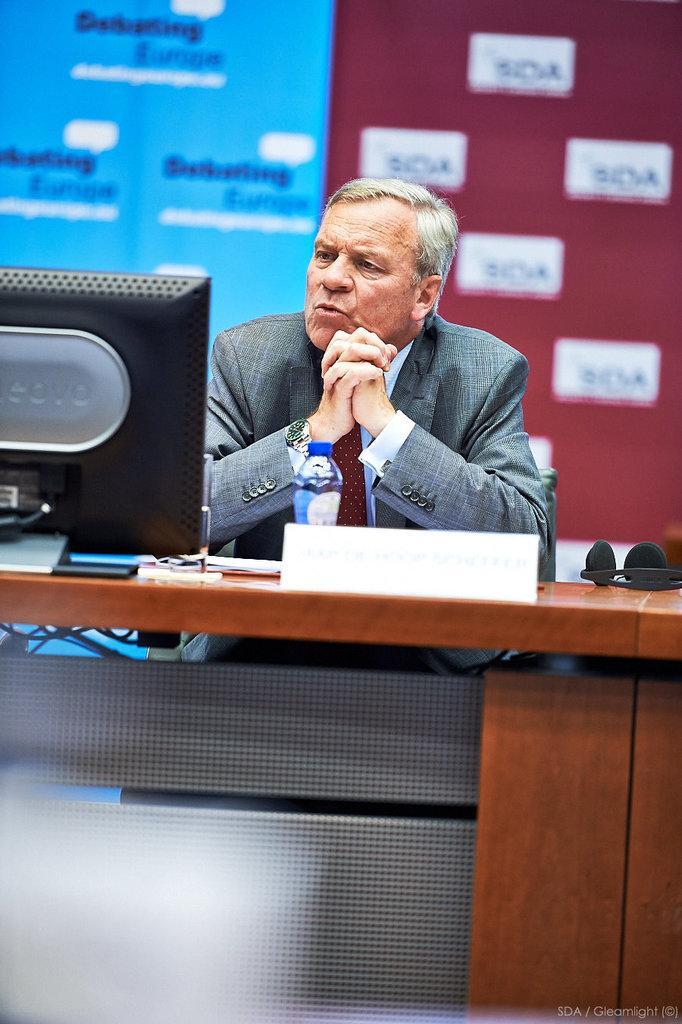Please provide a concise description of this image. In the foreground of this image, there is a man sitting in front of a table on which bottle, name board, papers and a monitor. In the background, there is a banner wall. 